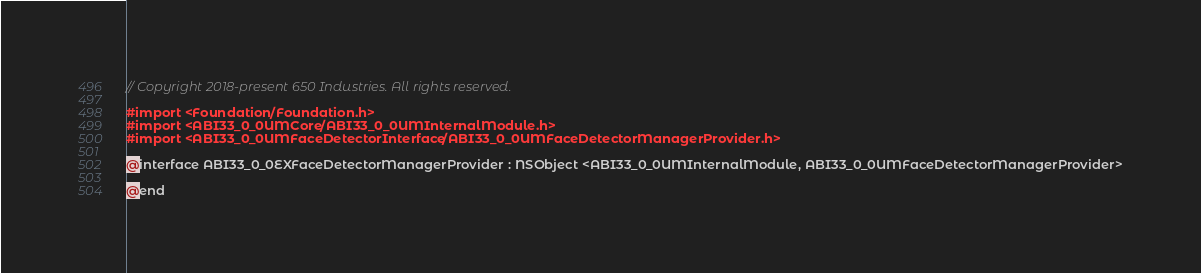<code> <loc_0><loc_0><loc_500><loc_500><_C_>// Copyright 2018-present 650 Industries. All rights reserved.

#import <Foundation/Foundation.h>
#import <ABI33_0_0UMCore/ABI33_0_0UMInternalModule.h>
#import <ABI33_0_0UMFaceDetectorInterface/ABI33_0_0UMFaceDetectorManagerProvider.h>

@interface ABI33_0_0EXFaceDetectorManagerProvider : NSObject <ABI33_0_0UMInternalModule, ABI33_0_0UMFaceDetectorManagerProvider>

@end
</code> 